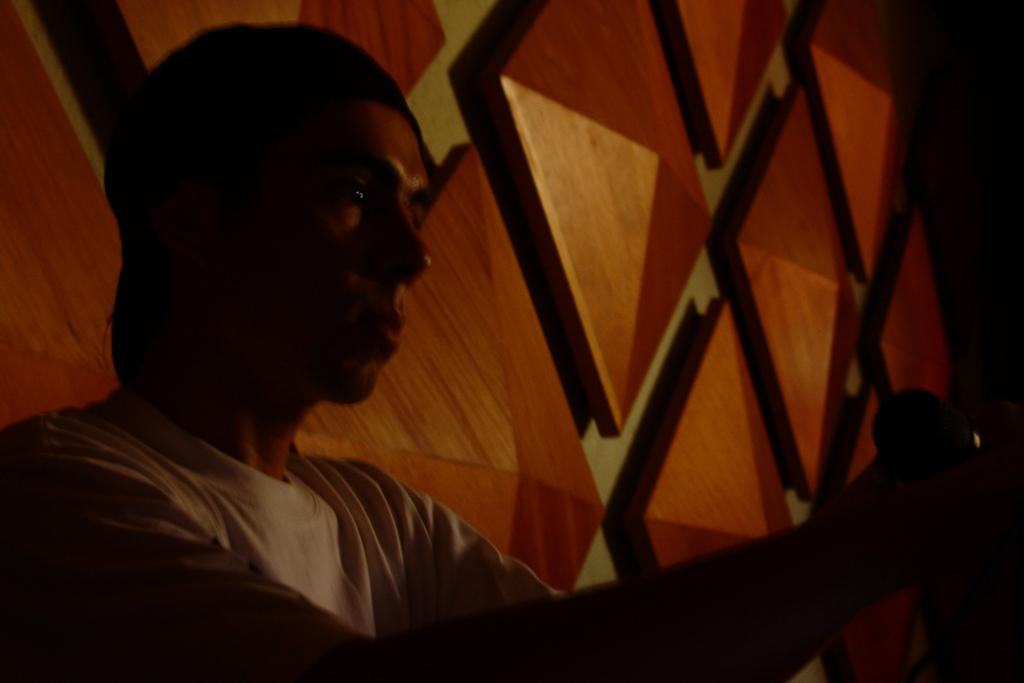What type of figure can be seen in the image? There is a human in the image. What material is the wall visible in the background made of? The wall in the background is made of wood. What scent is emanating from the floor in the image? There is no information about a scent in the image, and the floor is not mentioned in the provided facts. 